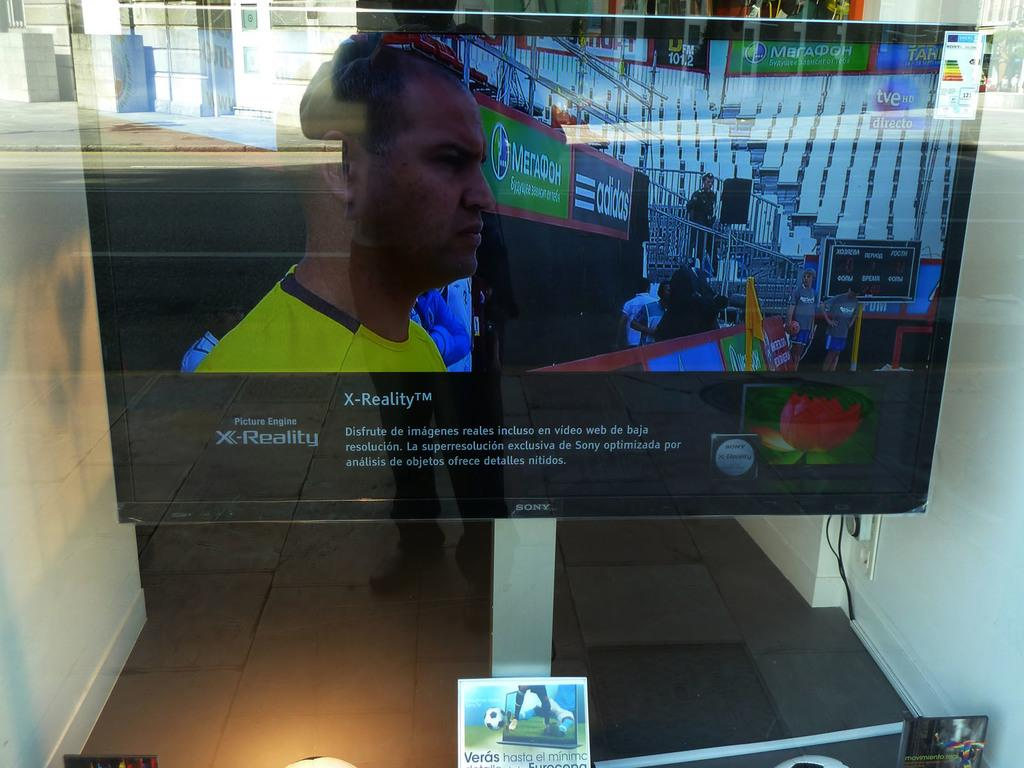<image>
Render a clear and concise summary of the photo. A screen says Picture Engine X-Reality and has a man on it. 